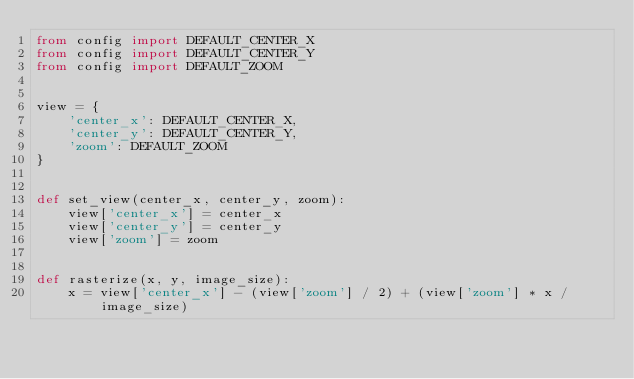Convert code to text. <code><loc_0><loc_0><loc_500><loc_500><_Python_>from config import DEFAULT_CENTER_X
from config import DEFAULT_CENTER_Y
from config import DEFAULT_ZOOM


view = {
    'center_x': DEFAULT_CENTER_X,
    'center_y': DEFAULT_CENTER_Y,
    'zoom': DEFAULT_ZOOM
}


def set_view(center_x, center_y, zoom):
    view['center_x'] = center_x
    view['center_y'] = center_y
    view['zoom'] = zoom


def rasterize(x, y, image_size):
    x = view['center_x'] - (view['zoom'] / 2) + (view['zoom'] * x / image_size)</code> 